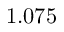Convert formula to latex. <formula><loc_0><loc_0><loc_500><loc_500>1 . 0 7 5</formula> 